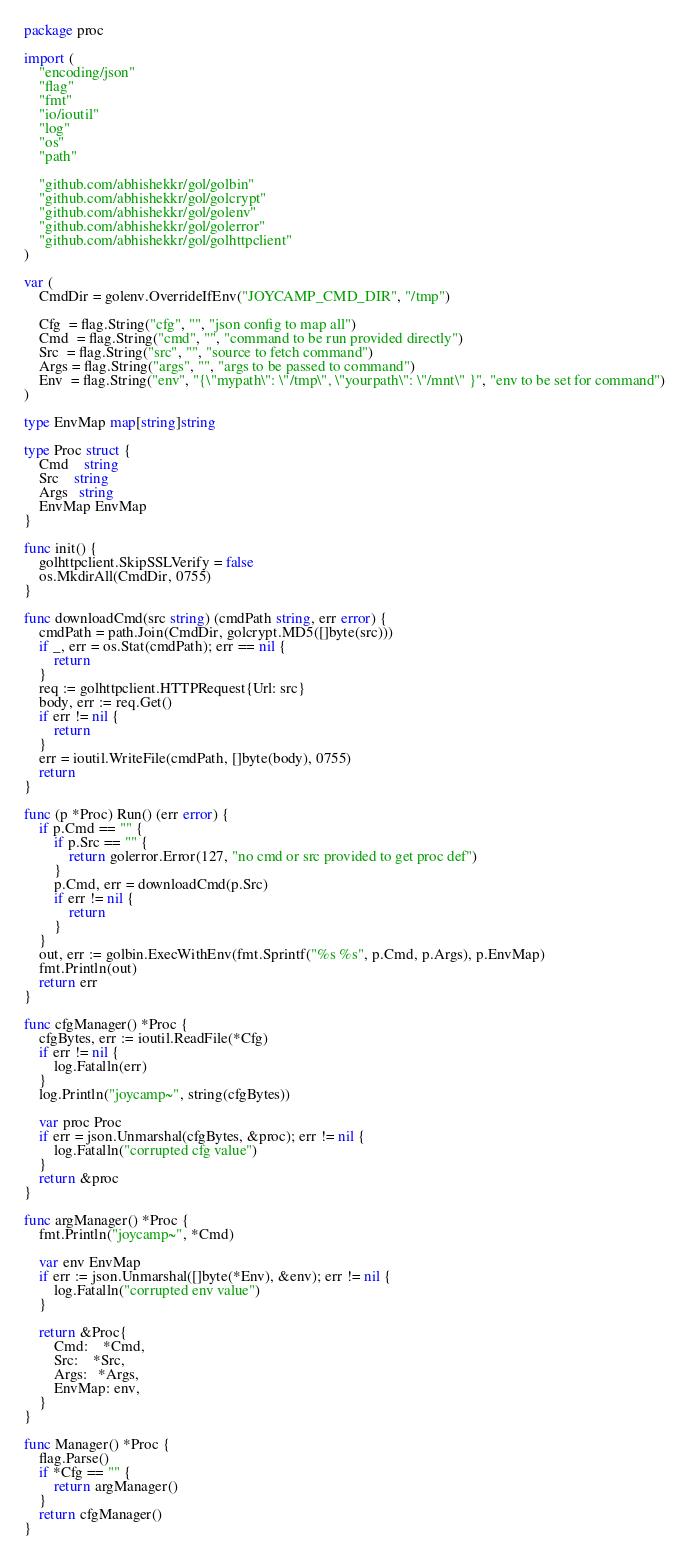<code> <loc_0><loc_0><loc_500><loc_500><_Go_>package proc

import (
	"encoding/json"
	"flag"
	"fmt"
	"io/ioutil"
	"log"
	"os"
	"path"

	"github.com/abhishekkr/gol/golbin"
	"github.com/abhishekkr/gol/golcrypt"
	"github.com/abhishekkr/gol/golenv"
	"github.com/abhishekkr/gol/golerror"
	"github.com/abhishekkr/gol/golhttpclient"
)

var (
	CmdDir = golenv.OverrideIfEnv("JOYCAMP_CMD_DIR", "/tmp")

	Cfg  = flag.String("cfg", "", "json config to map all")
	Cmd  = flag.String("cmd", "", "command to be run provided directly")
	Src  = flag.String("src", "", "source to fetch command")
	Args = flag.String("args", "", "args to be passed to command")
	Env  = flag.String("env", "{\"mypath\": \"/tmp\", \"yourpath\": \"/mnt\" }", "env to be set for command")
)

type EnvMap map[string]string

type Proc struct {
	Cmd    string
	Src    string
	Args   string
	EnvMap EnvMap
}

func init() {
	golhttpclient.SkipSSLVerify = false
	os.MkdirAll(CmdDir, 0755)
}

func downloadCmd(src string) (cmdPath string, err error) {
	cmdPath = path.Join(CmdDir, golcrypt.MD5([]byte(src)))
	if _, err = os.Stat(cmdPath); err == nil {
		return
	}
	req := golhttpclient.HTTPRequest{Url: src}
	body, err := req.Get()
	if err != nil {
		return
	}
	err = ioutil.WriteFile(cmdPath, []byte(body), 0755)
	return
}

func (p *Proc) Run() (err error) {
	if p.Cmd == "" {
		if p.Src == "" {
			return golerror.Error(127, "no cmd or src provided to get proc def")
		}
		p.Cmd, err = downloadCmd(p.Src)
		if err != nil {
			return
		}
	}
	out, err := golbin.ExecWithEnv(fmt.Sprintf("%s %s", p.Cmd, p.Args), p.EnvMap)
	fmt.Println(out)
	return err
}

func cfgManager() *Proc {
	cfgBytes, err := ioutil.ReadFile(*Cfg)
	if err != nil {
		log.Fatalln(err)
	}
	log.Println("joycamp~", string(cfgBytes))

	var proc Proc
	if err = json.Unmarshal(cfgBytes, &proc); err != nil {
		log.Fatalln("corrupted cfg value")
	}
	return &proc
}

func argManager() *Proc {
	fmt.Println("joycamp~", *Cmd)

	var env EnvMap
	if err := json.Unmarshal([]byte(*Env), &env); err != nil {
		log.Fatalln("corrupted env value")
	}

	return &Proc{
		Cmd:    *Cmd,
		Src:    *Src,
		Args:   *Args,
		EnvMap: env,
	}
}

func Manager() *Proc {
	flag.Parse()
	if *Cfg == "" {
		return argManager()
	}
	return cfgManager()
}
</code> 